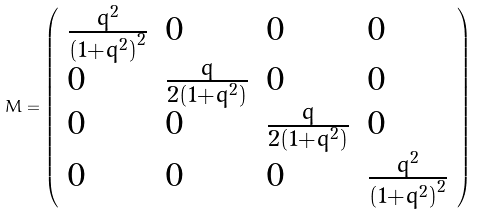Convert formula to latex. <formula><loc_0><loc_0><loc_500><loc_500>M = \left ( \begin{array} { l l l l } { { { \frac { { q ^ { 2 } } } { { { \left ( 1 + { q ^ { 2 } } \right ) } ^ { 2 } } } } } } & { 0 } & { 0 } & { 0 } \\ { 0 } & { { { \frac { q } { { { 2 \left ( 1 + { q ^ { 2 } } \right ) } } } } } } & { 0 } & { 0 } \\ { 0 } & { 0 } & { { { \frac { q } { { { 2 \left ( 1 + { q ^ { 2 } } \right ) } } } } } } & { 0 } \\ { 0 } & { 0 } & { 0 } & { { { \frac { { q ^ { 2 } } } { { { \left ( 1 + { q ^ { 2 } } \right ) } ^ { 2 } } } } } } \end{array} \right )</formula> 